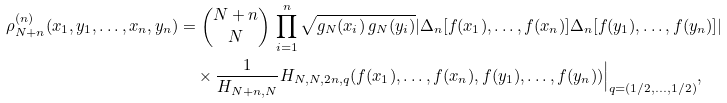<formula> <loc_0><loc_0><loc_500><loc_500>\rho _ { N + n } ^ { ( n ) } ( x _ { 1 } , y _ { 1 } , \dots , x _ { n } , y _ { n } ) & = \binom { N + n } { N } \, \prod _ { i = 1 } ^ { n } \sqrt { g _ { N } ( x _ { i } ) \, g _ { N } ( y _ { i } ) } | \Delta _ { n } [ f ( x _ { 1 } ) , \dots , f ( x _ { n } ) ] \Delta _ { n } [ f ( y _ { 1 } ) , \dots , f ( y _ { n } ) ] | \\ & \quad \times \frac { 1 } { H _ { N + n , N } } H _ { N , N , 2 n , q } ( f ( x _ { 1 } ) , \dots , f ( x _ { n } ) , f ( y _ { 1 } ) , \dots , f ( y _ { n } ) ) \Big | _ { q = ( 1 / 2 , \dots , 1 / 2 ) } ,</formula> 